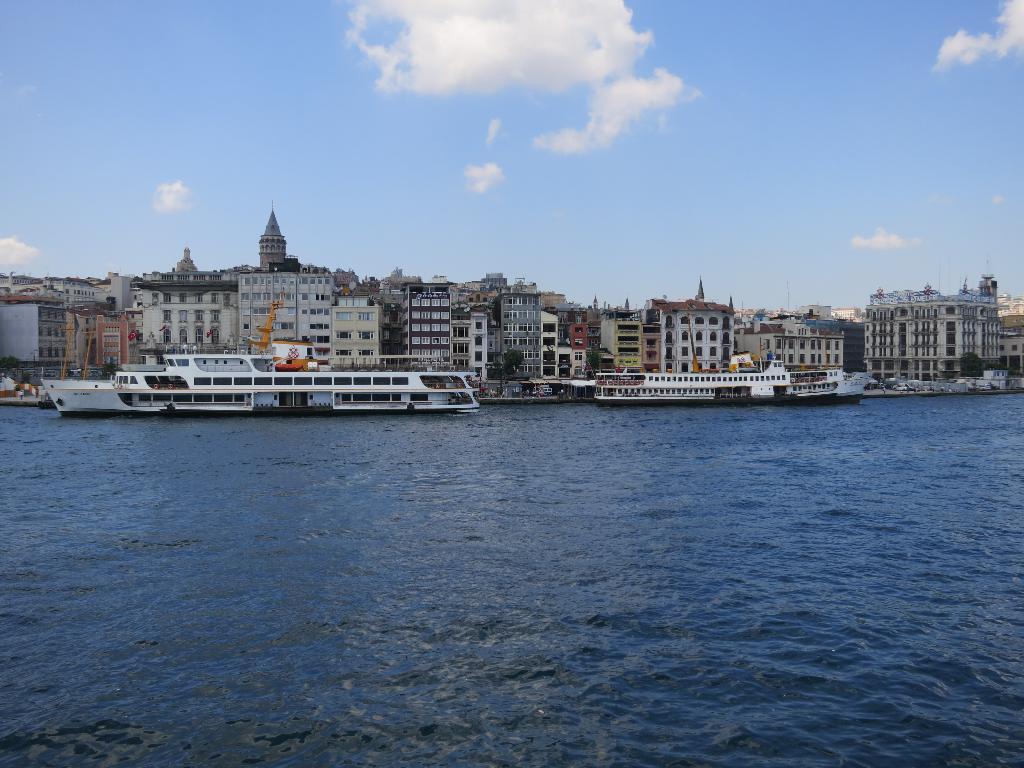Could you give a brief overview of what you see in this image? In this image at the bottom there is a beach, in that beach there are some boats. In the background there are some houses, trees, poles and some towers. On the top of the image there is sky. 